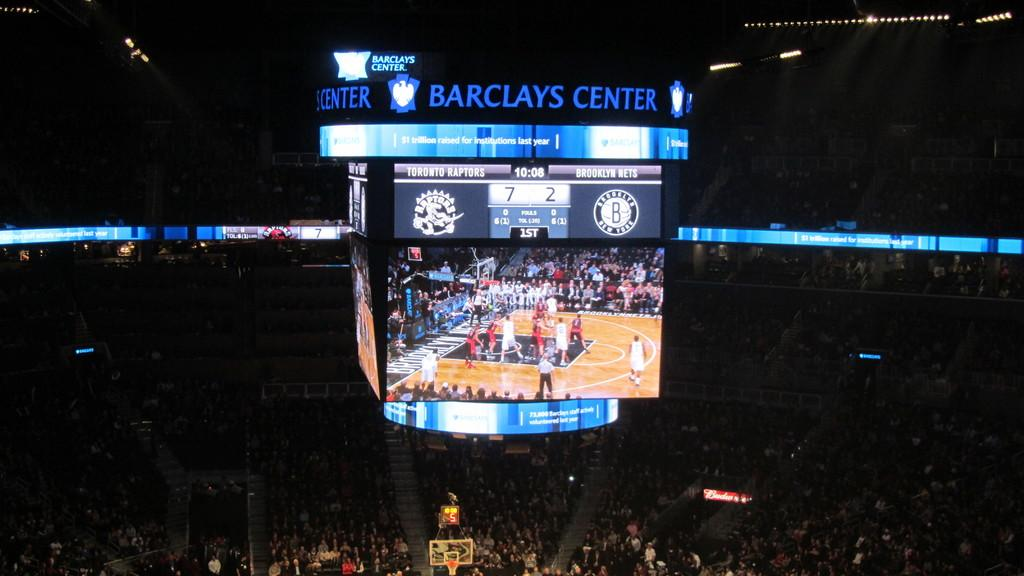<image>
Offer a succinct explanation of the picture presented. The large display at the Barclays Center arena. 